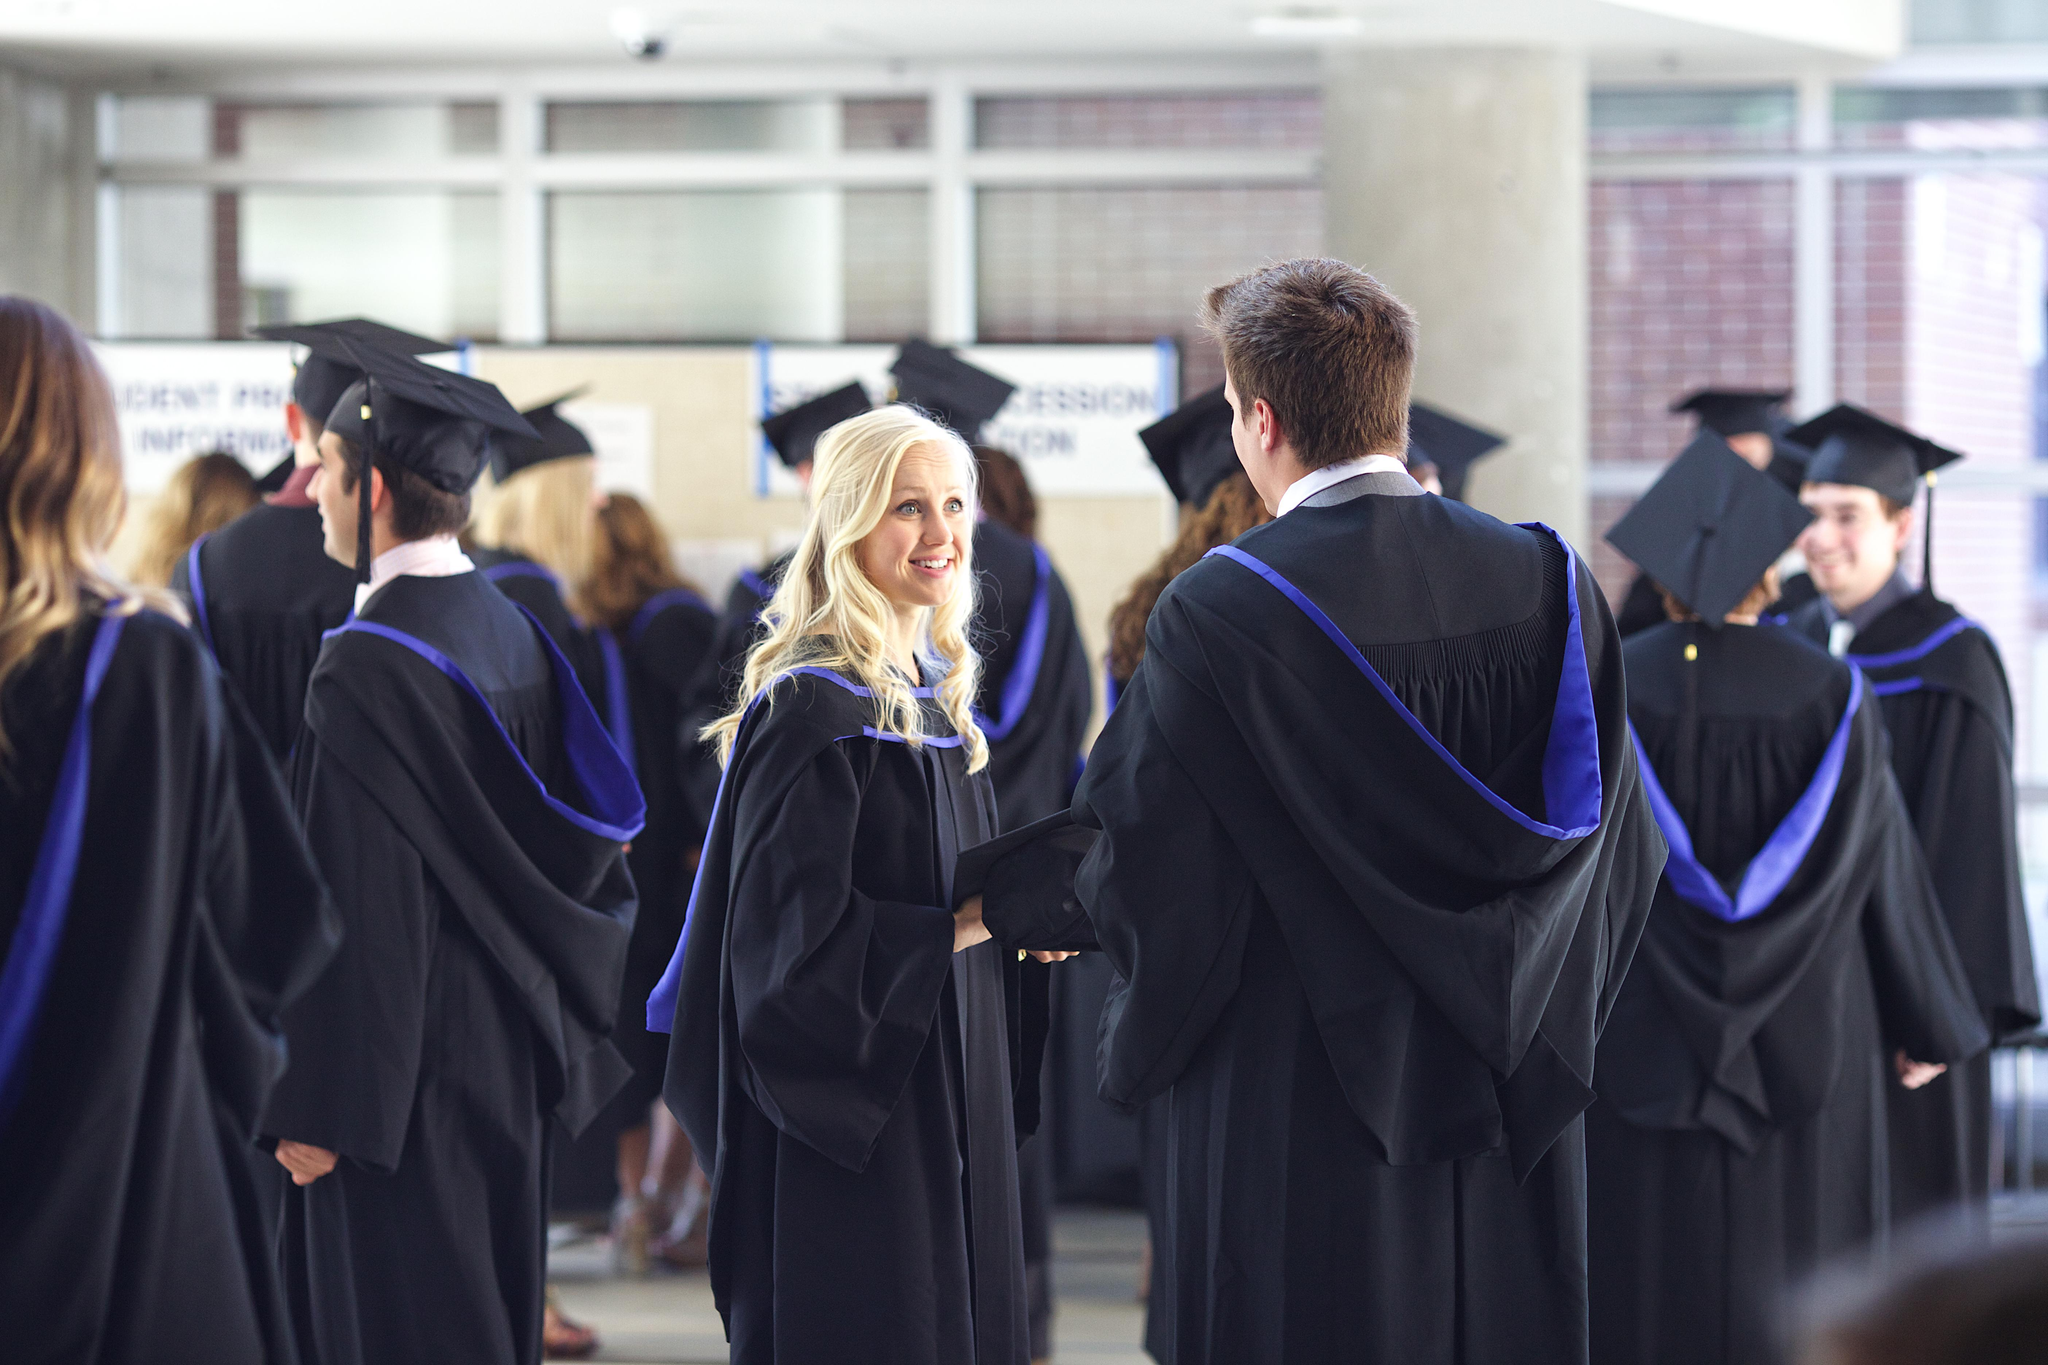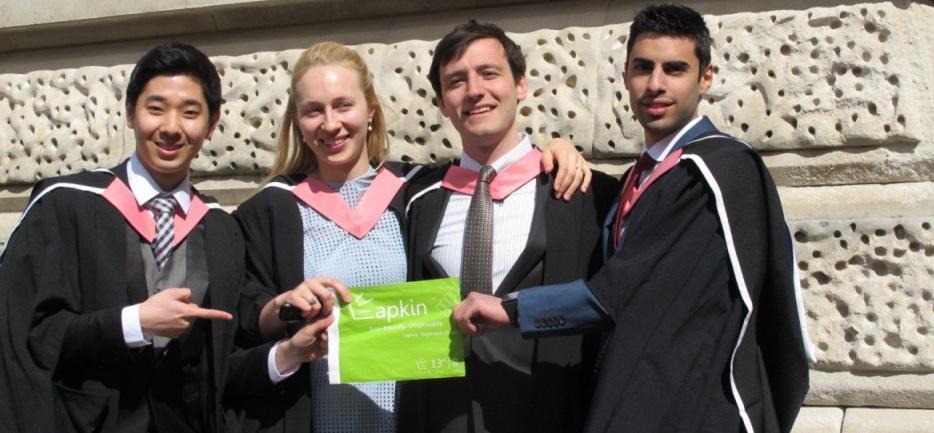The first image is the image on the left, the second image is the image on the right. For the images shown, is this caption "One image shows a single row of standing, camera-facing graduates numbering no more than four, and the other image includes at least some standing graduates who are not facing forward." true? Answer yes or no. Yes. 